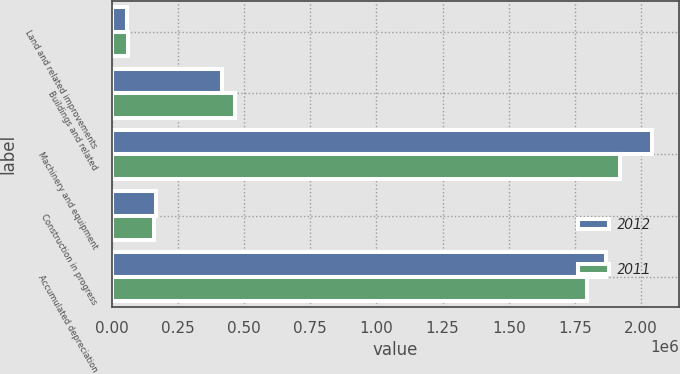Convert chart to OTSL. <chart><loc_0><loc_0><loc_500><loc_500><stacked_bar_chart><ecel><fcel>Land and related improvements<fcel>Buildings and related<fcel>Machinery and equipment<fcel>Construction in progress<fcel>Accumulated depreciation<nl><fcel>2012<fcel>57801<fcel>417316<fcel>2.04248e+06<fcel>167243<fcel>1.86938e+06<nl><fcel>2011<fcel>59995<fcel>466652<fcel>1.92048e+06<fcel>158237<fcel>1.79591e+06<nl></chart> 